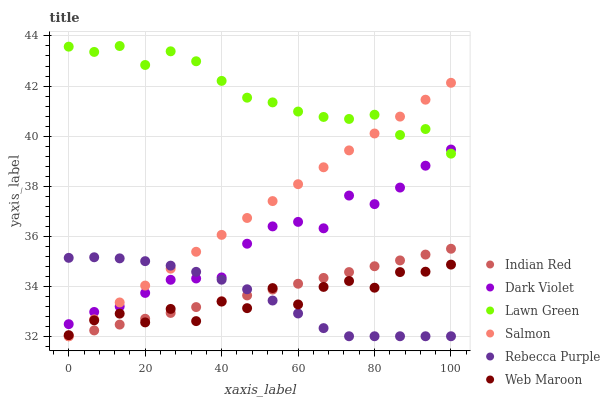Does Web Maroon have the minimum area under the curve?
Answer yes or no. Yes. Does Lawn Green have the maximum area under the curve?
Answer yes or no. Yes. Does Salmon have the minimum area under the curve?
Answer yes or no. No. Does Salmon have the maximum area under the curve?
Answer yes or no. No. Is Salmon the smoothest?
Answer yes or no. Yes. Is Web Maroon the roughest?
Answer yes or no. Yes. Is Web Maroon the smoothest?
Answer yes or no. No. Is Salmon the roughest?
Answer yes or no. No. Does Salmon have the lowest value?
Answer yes or no. Yes. Does Web Maroon have the lowest value?
Answer yes or no. No. Does Lawn Green have the highest value?
Answer yes or no. Yes. Does Salmon have the highest value?
Answer yes or no. No. Is Web Maroon less than Dark Violet?
Answer yes or no. Yes. Is Lawn Green greater than Indian Red?
Answer yes or no. Yes. Does Salmon intersect Lawn Green?
Answer yes or no. Yes. Is Salmon less than Lawn Green?
Answer yes or no. No. Is Salmon greater than Lawn Green?
Answer yes or no. No. Does Web Maroon intersect Dark Violet?
Answer yes or no. No. 